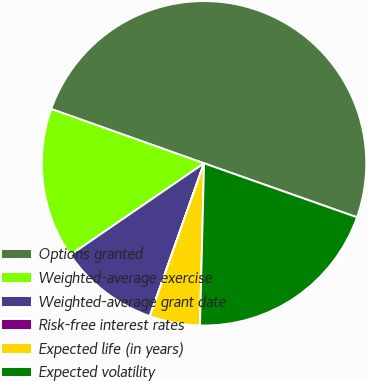<chart> <loc_0><loc_0><loc_500><loc_500><pie_chart><fcel>Options granted<fcel>Weighted-average exercise<fcel>Weighted-average grant date<fcel>Risk-free interest rates<fcel>Expected life (in years)<fcel>Expected volatility<nl><fcel>49.97%<fcel>15.0%<fcel>10.01%<fcel>0.02%<fcel>5.01%<fcel>20.0%<nl></chart> 